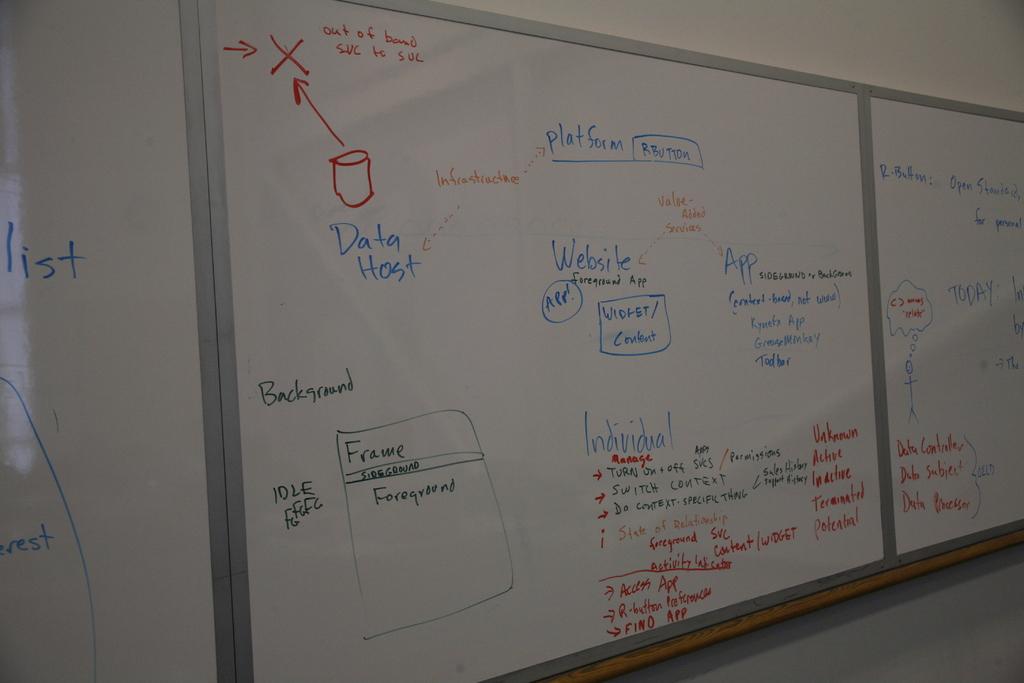What does the red square symbolize?
Provide a succinct answer. Data host. 